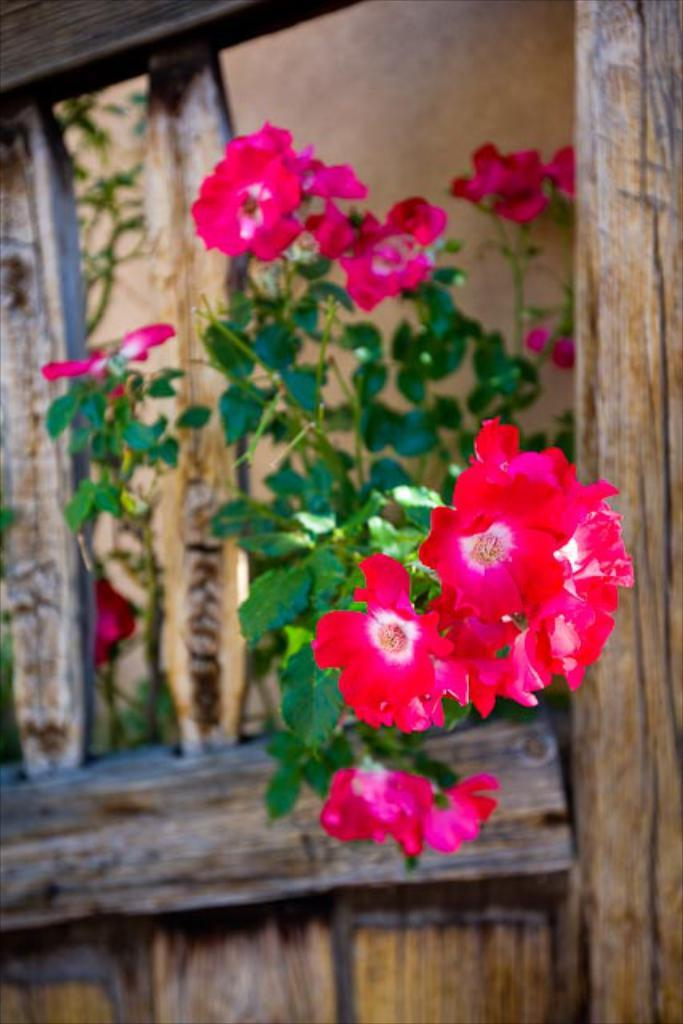What type of living organism can be seen in the image? There is a plant in the image. What material is the wooden object or structure made of? The wooden object or structure is made of wood. What type of cracker is being used for digestion in the image? There is no cracker or reference to digestion present in the image. What type of flag is visible in the image? There is no flag present in the image. 